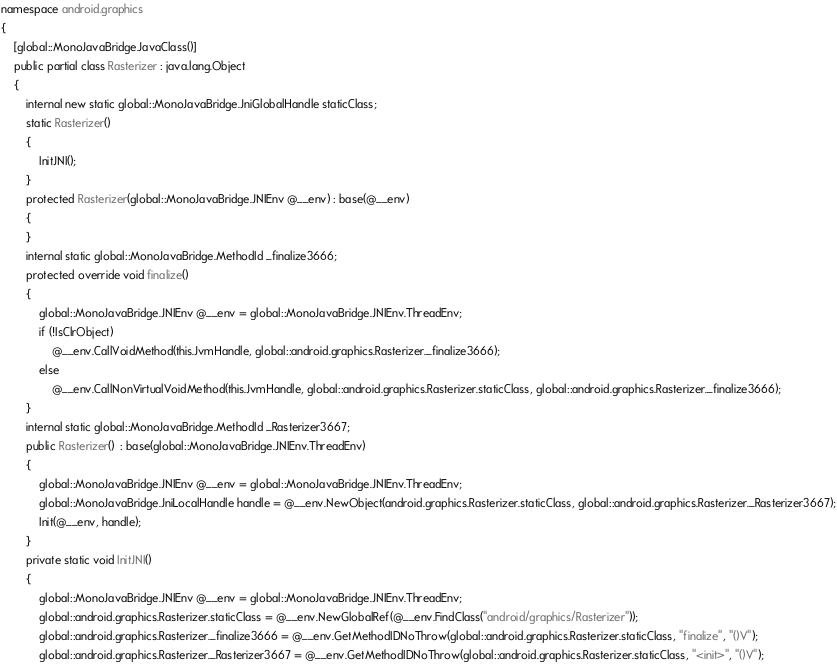<code> <loc_0><loc_0><loc_500><loc_500><_C#_>namespace android.graphics
{
	[global::MonoJavaBridge.JavaClass()]
	public partial class Rasterizer : java.lang.Object
	{
		internal new static global::MonoJavaBridge.JniGlobalHandle staticClass;
		static Rasterizer()
		{
			InitJNI();
		}
		protected Rasterizer(global::MonoJavaBridge.JNIEnv @__env) : base(@__env)
		{
		}
		internal static global::MonoJavaBridge.MethodId _finalize3666;
		protected override void finalize() 
		{
			global::MonoJavaBridge.JNIEnv @__env = global::MonoJavaBridge.JNIEnv.ThreadEnv;
			if (!IsClrObject)
				@__env.CallVoidMethod(this.JvmHandle, global::android.graphics.Rasterizer._finalize3666);
			else
				@__env.CallNonVirtualVoidMethod(this.JvmHandle, global::android.graphics.Rasterizer.staticClass, global::android.graphics.Rasterizer._finalize3666);
		}
		internal static global::MonoJavaBridge.MethodId _Rasterizer3667;
		public Rasterizer()  : base(global::MonoJavaBridge.JNIEnv.ThreadEnv) 
		{
			global::MonoJavaBridge.JNIEnv @__env = global::MonoJavaBridge.JNIEnv.ThreadEnv;
			global::MonoJavaBridge.JniLocalHandle handle = @__env.NewObject(android.graphics.Rasterizer.staticClass, global::android.graphics.Rasterizer._Rasterizer3667);
			Init(@__env, handle);
		}
		private static void InitJNI()
		{
			global::MonoJavaBridge.JNIEnv @__env = global::MonoJavaBridge.JNIEnv.ThreadEnv;
			global::android.graphics.Rasterizer.staticClass = @__env.NewGlobalRef(@__env.FindClass("android/graphics/Rasterizer"));
			global::android.graphics.Rasterizer._finalize3666 = @__env.GetMethodIDNoThrow(global::android.graphics.Rasterizer.staticClass, "finalize", "()V");
			global::android.graphics.Rasterizer._Rasterizer3667 = @__env.GetMethodIDNoThrow(global::android.graphics.Rasterizer.staticClass, "<init>", "()V");</code> 